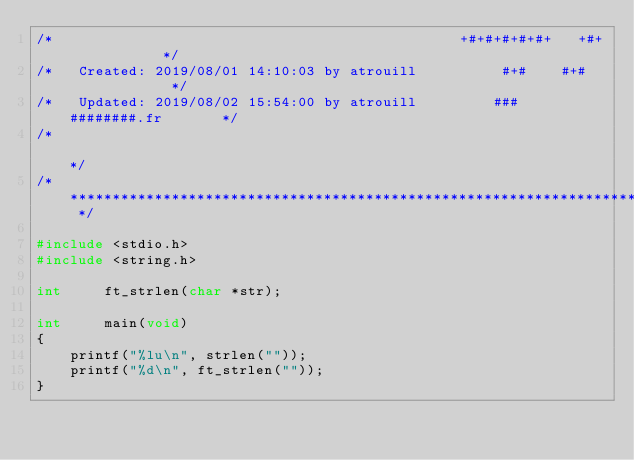<code> <loc_0><loc_0><loc_500><loc_500><_C_>/*                                                +#+#+#+#+#+   +#+           */
/*   Created: 2019/08/01 14:10:03 by atrouill          #+#    #+#             */
/*   Updated: 2019/08/02 15:54:00 by atrouill         ###   ########.fr       */
/*                                                                            */
/* ************************************************************************** */

#include <stdio.h>
#include <string.h>

int		ft_strlen(char *str);

int		main(void)
{
	printf("%lu\n", strlen(""));
	printf("%d\n", ft_strlen(""));
}
</code> 